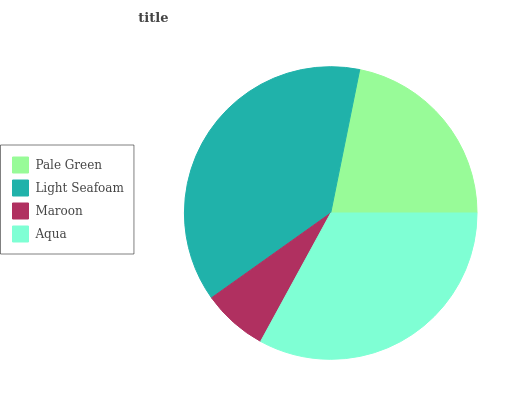Is Maroon the minimum?
Answer yes or no. Yes. Is Light Seafoam the maximum?
Answer yes or no. Yes. Is Light Seafoam the minimum?
Answer yes or no. No. Is Maroon the maximum?
Answer yes or no. No. Is Light Seafoam greater than Maroon?
Answer yes or no. Yes. Is Maroon less than Light Seafoam?
Answer yes or no. Yes. Is Maroon greater than Light Seafoam?
Answer yes or no. No. Is Light Seafoam less than Maroon?
Answer yes or no. No. Is Aqua the high median?
Answer yes or no. Yes. Is Pale Green the low median?
Answer yes or no. Yes. Is Maroon the high median?
Answer yes or no. No. Is Maroon the low median?
Answer yes or no. No. 